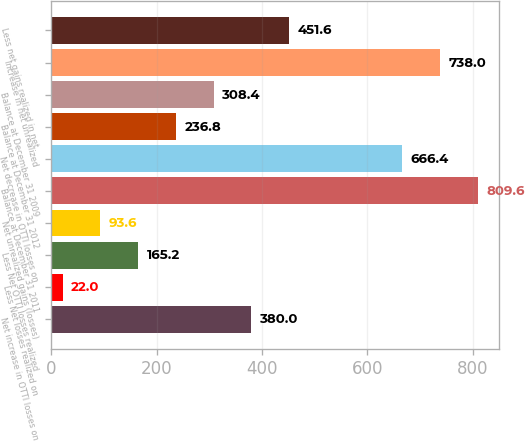Convert chart. <chart><loc_0><loc_0><loc_500><loc_500><bar_chart><fcel>Net increase in OTTI losses on<fcel>Less Net losses realized on<fcel>Less Net OTTI losses realized<fcel>Net unrealized gains (losses)<fcel>Balance at December 31 2011<fcel>Net decrease in OTTI losses on<fcel>Balance at December 31 2012<fcel>Balance at December 31 2009<fcel>Increase in net unrealized<fcel>Less net gains realized in net<nl><fcel>380<fcel>22<fcel>165.2<fcel>93.6<fcel>809.6<fcel>666.4<fcel>236.8<fcel>308.4<fcel>738<fcel>451.6<nl></chart> 